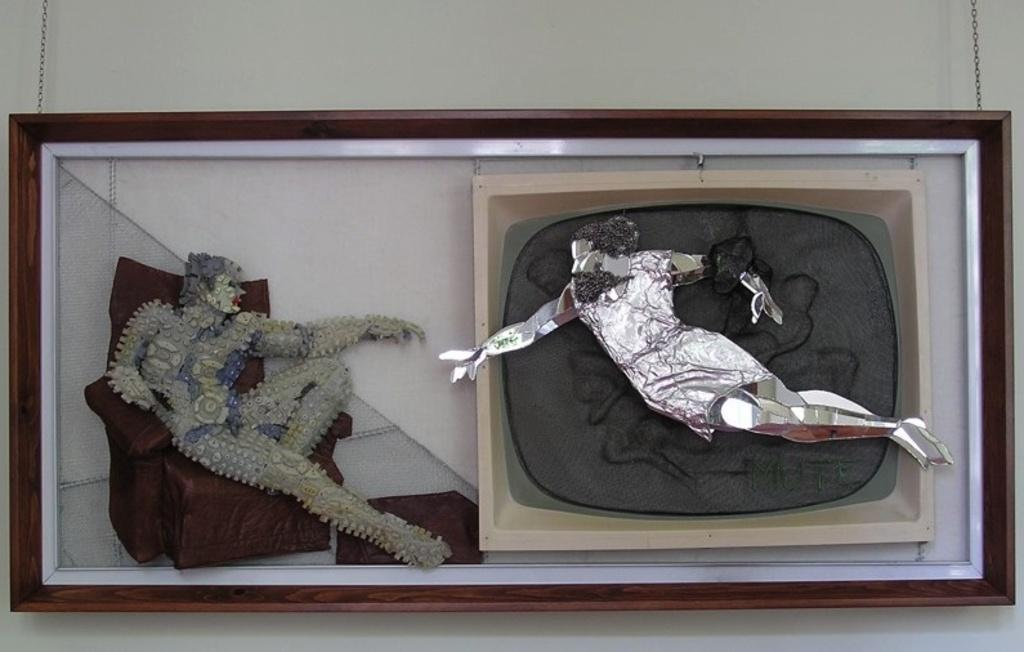What is present on the wall in the image? There is art on the wall in the image. What is depicted in the art? The art features a sofa. Are there any people in the art? Yes, there are two persons in the art. What type of sleet can be seen falling on the sofa in the art? There is no sleet present in the image; the art features a sofa and two persons, but no weather conditions are depicted. 